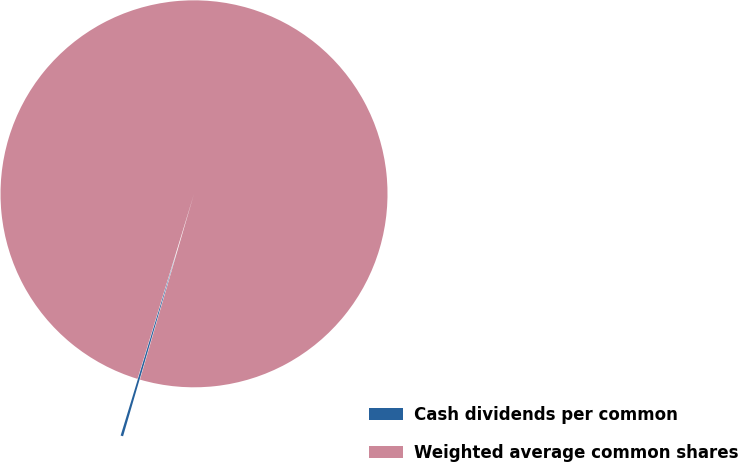Convert chart. <chart><loc_0><loc_0><loc_500><loc_500><pie_chart><fcel>Cash dividends per common<fcel>Weighted average common shares<nl><fcel>0.21%<fcel>99.79%<nl></chart> 